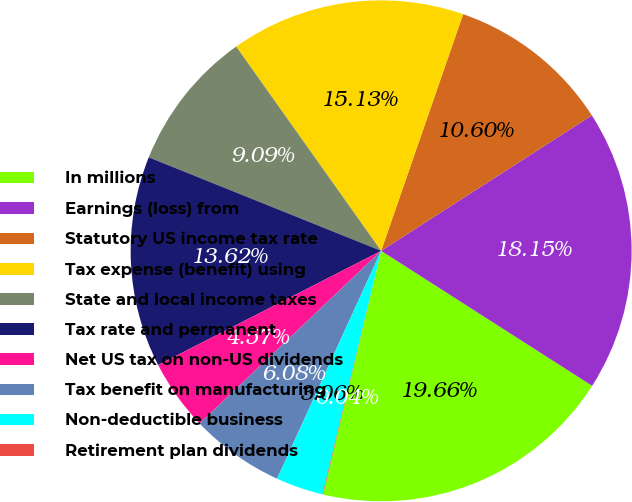<chart> <loc_0><loc_0><loc_500><loc_500><pie_chart><fcel>In millions<fcel>Earnings (loss) from<fcel>Statutory US income tax rate<fcel>Tax expense (benefit) using<fcel>State and local income taxes<fcel>Tax rate and permanent<fcel>Net US tax on non-US dividends<fcel>Tax benefit on manufacturing<fcel>Non-deductible business<fcel>Retirement plan dividends<nl><fcel>19.66%<fcel>18.15%<fcel>10.6%<fcel>15.13%<fcel>9.09%<fcel>13.62%<fcel>4.57%<fcel>6.08%<fcel>3.06%<fcel>0.04%<nl></chart> 